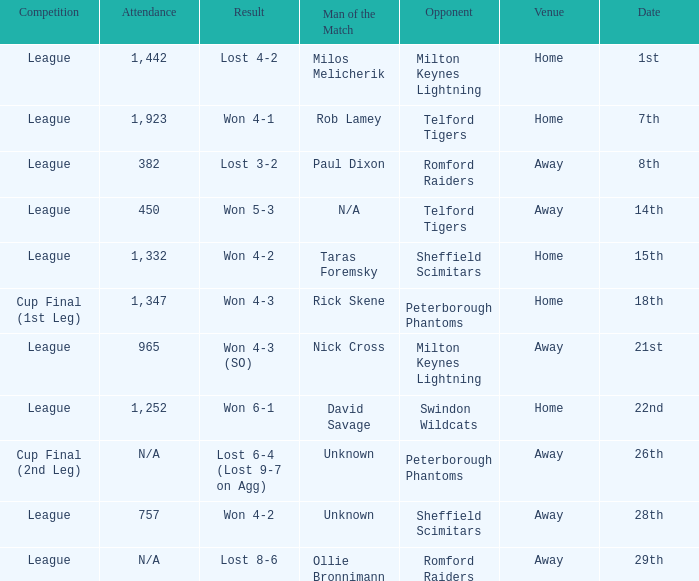On what date was the venue Away and the result was lost 6-4 (lost 9-7 on agg)? 26th. 